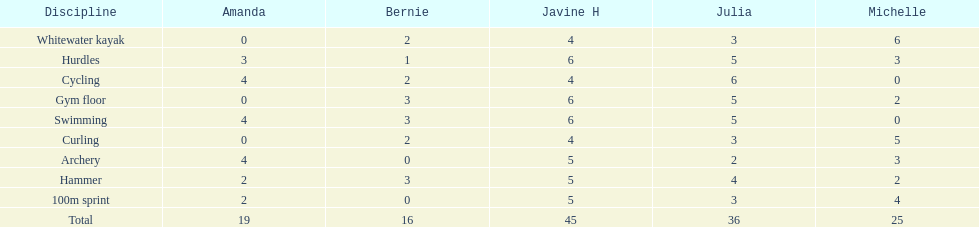On this chart, which is the last discipline displayed? 100m sprint. 